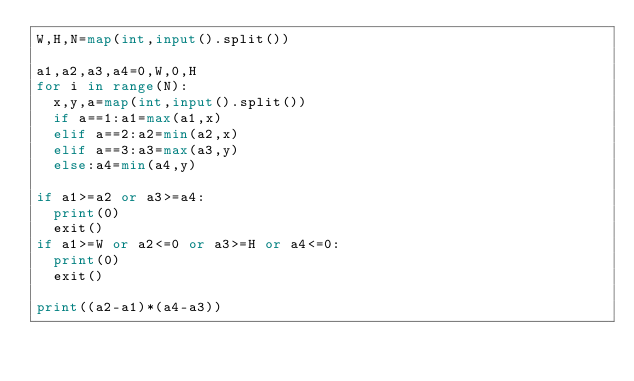Convert code to text. <code><loc_0><loc_0><loc_500><loc_500><_Python_>W,H,N=map(int,input().split())

a1,a2,a3,a4=0,W,0,H
for i in range(N):
  x,y,a=map(int,input().split())
  if a==1:a1=max(a1,x)
  elif a==2:a2=min(a2,x)
  elif a==3:a3=max(a3,y)
  else:a4=min(a4,y)
    
if a1>=a2 or a3>=a4:
  print(0)
  exit()
if a1>=W or a2<=0 or a3>=H or a4<=0:
  print(0)
  exit()
  
print((a2-a1)*(a4-a3))</code> 